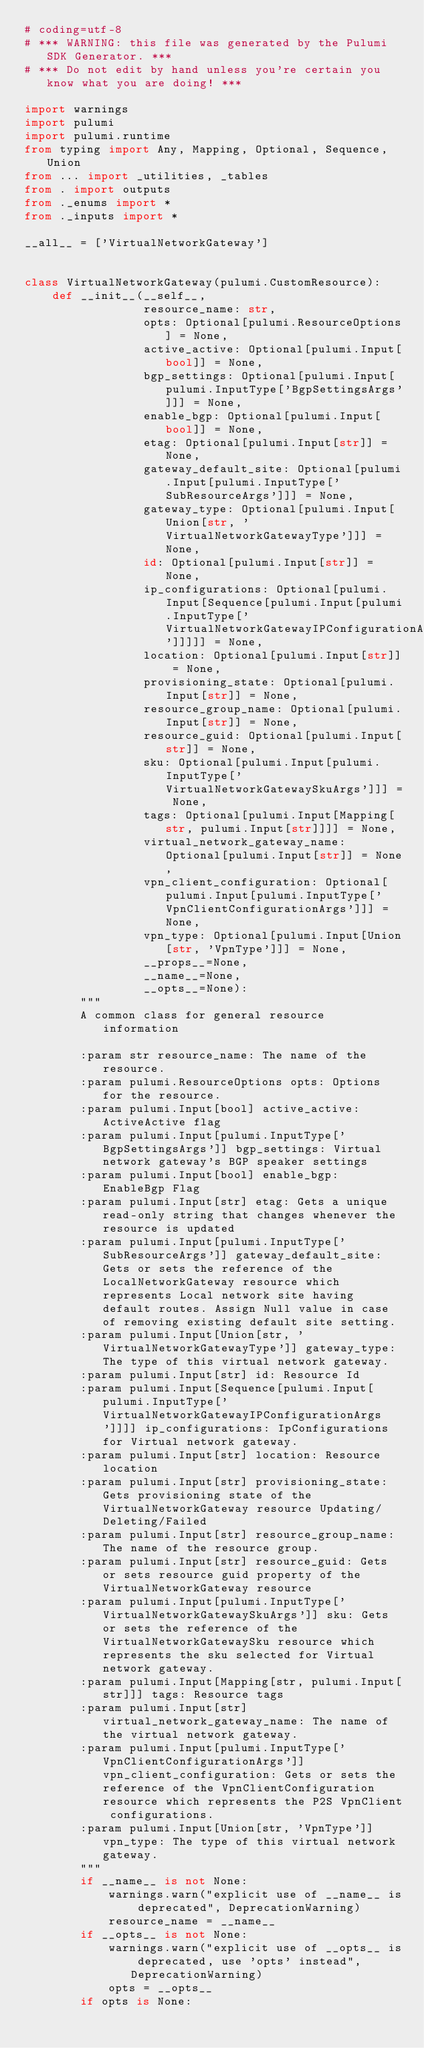<code> <loc_0><loc_0><loc_500><loc_500><_Python_># coding=utf-8
# *** WARNING: this file was generated by the Pulumi SDK Generator. ***
# *** Do not edit by hand unless you're certain you know what you are doing! ***

import warnings
import pulumi
import pulumi.runtime
from typing import Any, Mapping, Optional, Sequence, Union
from ... import _utilities, _tables
from . import outputs
from ._enums import *
from ._inputs import *

__all__ = ['VirtualNetworkGateway']


class VirtualNetworkGateway(pulumi.CustomResource):
    def __init__(__self__,
                 resource_name: str,
                 opts: Optional[pulumi.ResourceOptions] = None,
                 active_active: Optional[pulumi.Input[bool]] = None,
                 bgp_settings: Optional[pulumi.Input[pulumi.InputType['BgpSettingsArgs']]] = None,
                 enable_bgp: Optional[pulumi.Input[bool]] = None,
                 etag: Optional[pulumi.Input[str]] = None,
                 gateway_default_site: Optional[pulumi.Input[pulumi.InputType['SubResourceArgs']]] = None,
                 gateway_type: Optional[pulumi.Input[Union[str, 'VirtualNetworkGatewayType']]] = None,
                 id: Optional[pulumi.Input[str]] = None,
                 ip_configurations: Optional[pulumi.Input[Sequence[pulumi.Input[pulumi.InputType['VirtualNetworkGatewayIPConfigurationArgs']]]]] = None,
                 location: Optional[pulumi.Input[str]] = None,
                 provisioning_state: Optional[pulumi.Input[str]] = None,
                 resource_group_name: Optional[pulumi.Input[str]] = None,
                 resource_guid: Optional[pulumi.Input[str]] = None,
                 sku: Optional[pulumi.Input[pulumi.InputType['VirtualNetworkGatewaySkuArgs']]] = None,
                 tags: Optional[pulumi.Input[Mapping[str, pulumi.Input[str]]]] = None,
                 virtual_network_gateway_name: Optional[pulumi.Input[str]] = None,
                 vpn_client_configuration: Optional[pulumi.Input[pulumi.InputType['VpnClientConfigurationArgs']]] = None,
                 vpn_type: Optional[pulumi.Input[Union[str, 'VpnType']]] = None,
                 __props__=None,
                 __name__=None,
                 __opts__=None):
        """
        A common class for general resource information

        :param str resource_name: The name of the resource.
        :param pulumi.ResourceOptions opts: Options for the resource.
        :param pulumi.Input[bool] active_active: ActiveActive flag
        :param pulumi.Input[pulumi.InputType['BgpSettingsArgs']] bgp_settings: Virtual network gateway's BGP speaker settings
        :param pulumi.Input[bool] enable_bgp: EnableBgp Flag
        :param pulumi.Input[str] etag: Gets a unique read-only string that changes whenever the resource is updated
        :param pulumi.Input[pulumi.InputType['SubResourceArgs']] gateway_default_site: Gets or sets the reference of the LocalNetworkGateway resource which represents Local network site having default routes. Assign Null value in case of removing existing default site setting.
        :param pulumi.Input[Union[str, 'VirtualNetworkGatewayType']] gateway_type: The type of this virtual network gateway.
        :param pulumi.Input[str] id: Resource Id
        :param pulumi.Input[Sequence[pulumi.Input[pulumi.InputType['VirtualNetworkGatewayIPConfigurationArgs']]]] ip_configurations: IpConfigurations for Virtual network gateway.
        :param pulumi.Input[str] location: Resource location
        :param pulumi.Input[str] provisioning_state: Gets provisioning state of the VirtualNetworkGateway resource Updating/Deleting/Failed
        :param pulumi.Input[str] resource_group_name: The name of the resource group.
        :param pulumi.Input[str] resource_guid: Gets or sets resource guid property of the VirtualNetworkGateway resource
        :param pulumi.Input[pulumi.InputType['VirtualNetworkGatewaySkuArgs']] sku: Gets or sets the reference of the VirtualNetworkGatewaySku resource which represents the sku selected for Virtual network gateway.
        :param pulumi.Input[Mapping[str, pulumi.Input[str]]] tags: Resource tags
        :param pulumi.Input[str] virtual_network_gateway_name: The name of the virtual network gateway.
        :param pulumi.Input[pulumi.InputType['VpnClientConfigurationArgs']] vpn_client_configuration: Gets or sets the reference of the VpnClientConfiguration resource which represents the P2S VpnClient configurations.
        :param pulumi.Input[Union[str, 'VpnType']] vpn_type: The type of this virtual network gateway.
        """
        if __name__ is not None:
            warnings.warn("explicit use of __name__ is deprecated", DeprecationWarning)
            resource_name = __name__
        if __opts__ is not None:
            warnings.warn("explicit use of __opts__ is deprecated, use 'opts' instead", DeprecationWarning)
            opts = __opts__
        if opts is None:</code> 